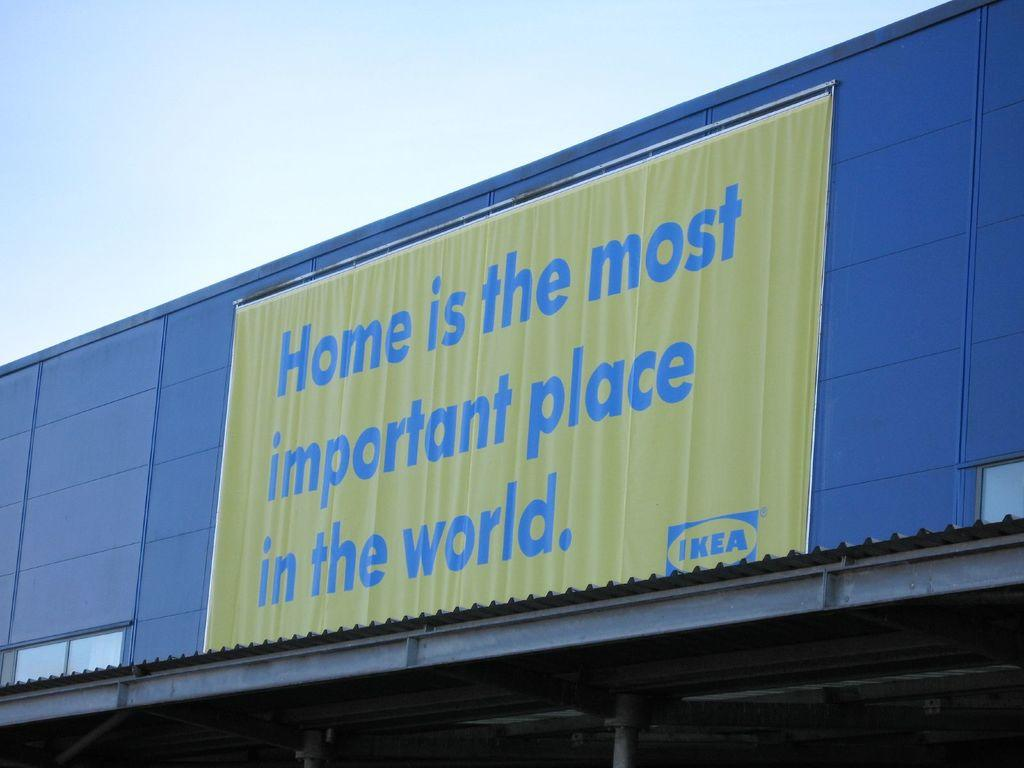<image>
Write a terse but informative summary of the picture. A store front of IKEA store with a banner that says "Home is the most important place in the world.". 